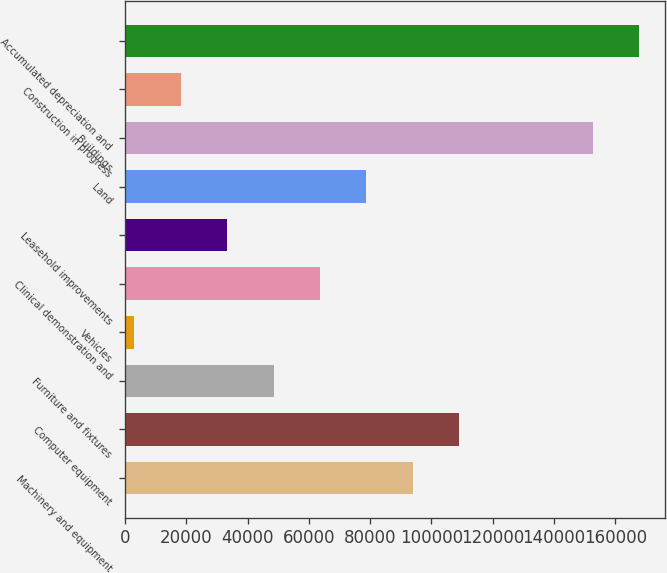Convert chart. <chart><loc_0><loc_0><loc_500><loc_500><bar_chart><fcel>Machinery and equipment<fcel>Computer equipment<fcel>Furniture and fixtures<fcel>Vehicles<fcel>Clinical demonstration and<fcel>Leasehold improvements<fcel>Land<fcel>Buildings<fcel>Construction in progress<fcel>Accumulated depreciation and<nl><fcel>93929.4<fcel>109087<fcel>48457.2<fcel>2985<fcel>63614.6<fcel>33299.8<fcel>78772<fcel>152691<fcel>18142.4<fcel>167848<nl></chart> 